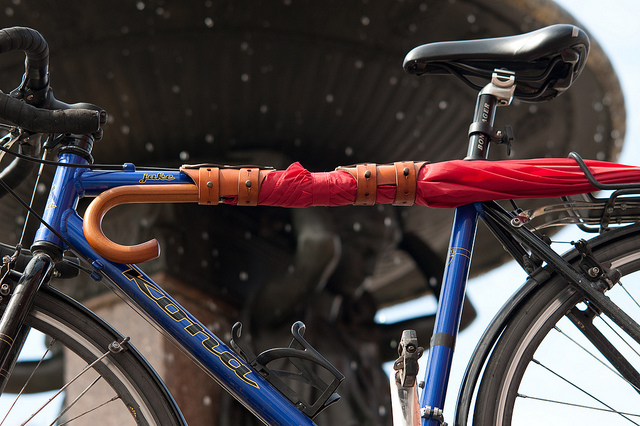Read and extract the text from this image. Kona 